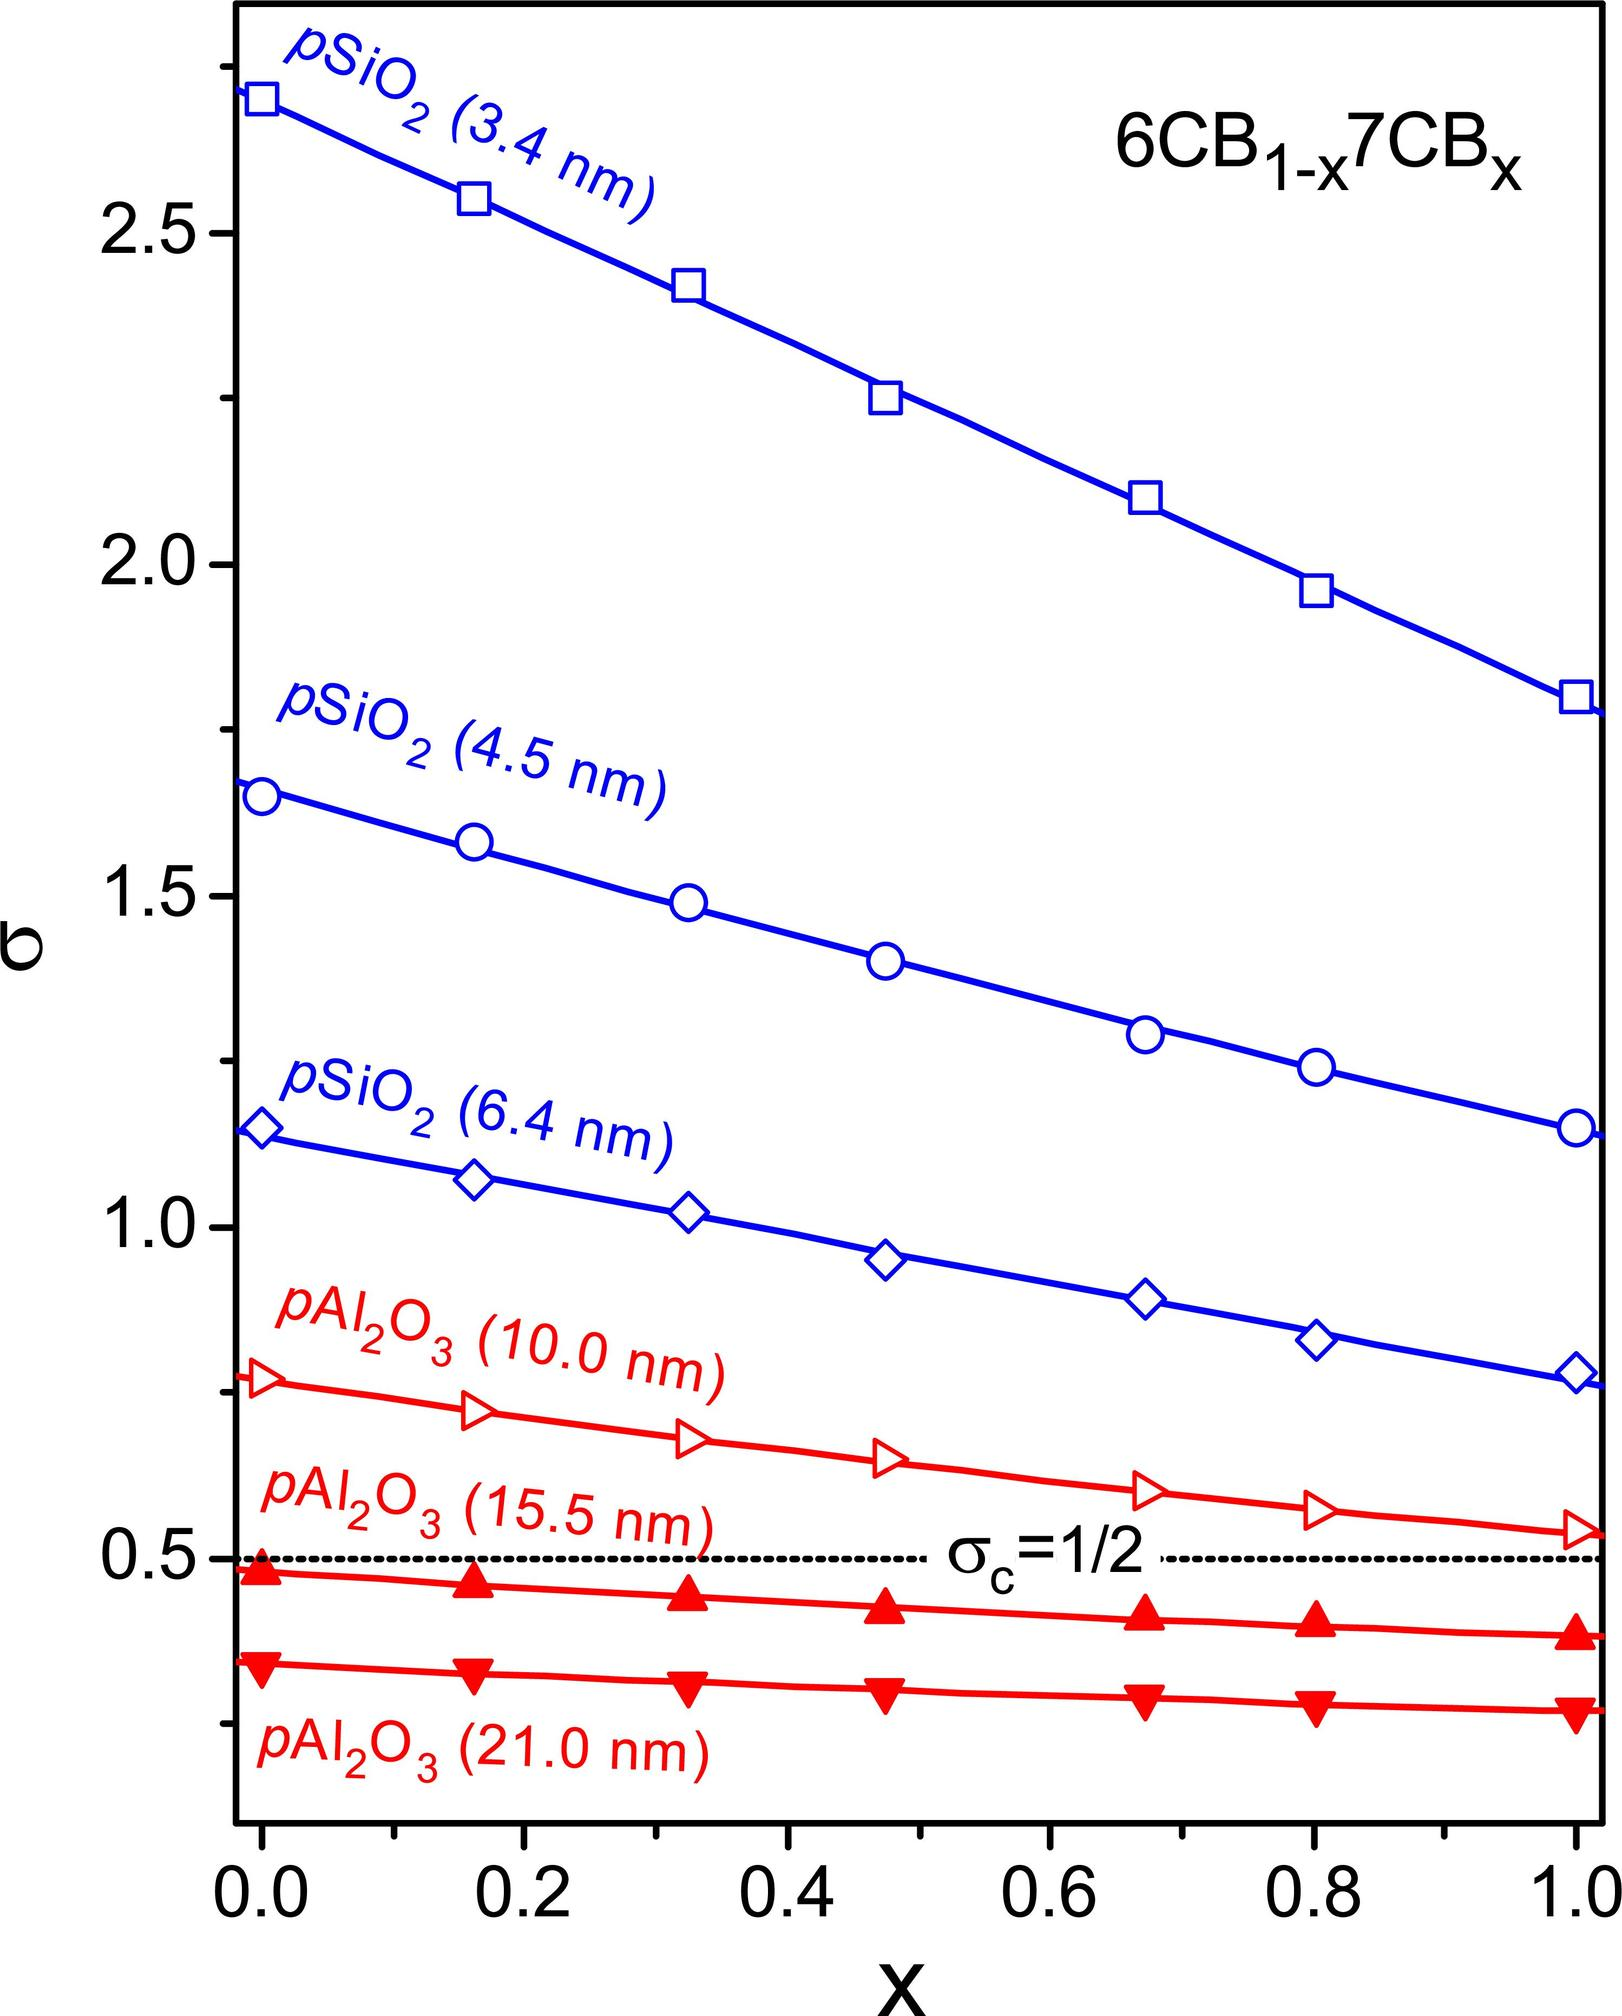What does the dashed line labeled 'σ_C=1/2' on the graph indicate? The dashed line labeled 'σ_C=1/2' represents a critical value or threshold. In this context, σ_C likely stands for critical segregation strength, a term used in the study of phase transitions in mixtures. The number 1/2 suggests a point at which the mixture undergoes a change, such as transitioning from a uniform to a segregated phase. The significance of this line is to denote a particular ratio (or fraction 'x') at which the behavior or properties of the mixture significantly change, which is crucial for predictions about the stability and properties of the materials. 